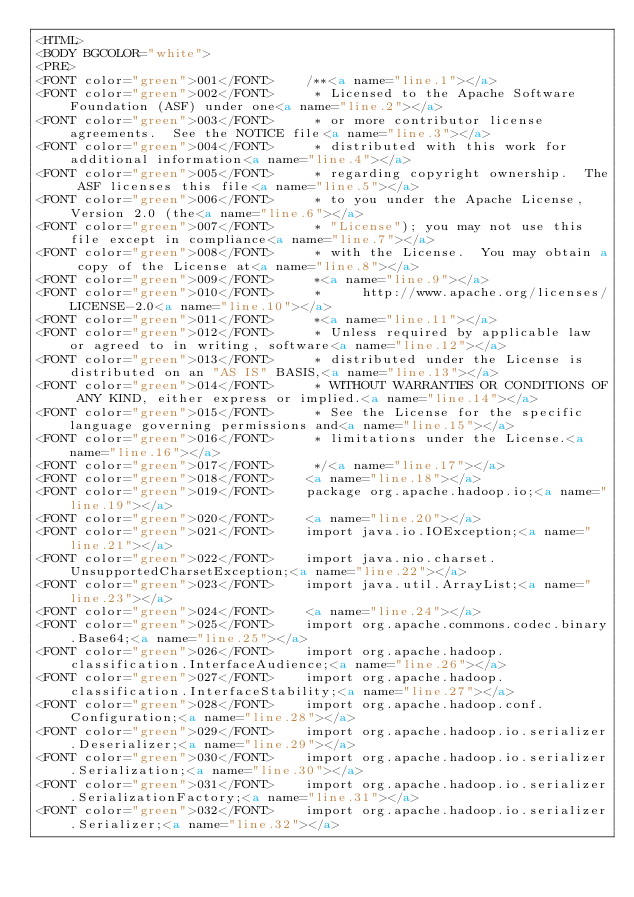<code> <loc_0><loc_0><loc_500><loc_500><_HTML_><HTML>
<BODY BGCOLOR="white">
<PRE>
<FONT color="green">001</FONT>    /**<a name="line.1"></a>
<FONT color="green">002</FONT>     * Licensed to the Apache Software Foundation (ASF) under one<a name="line.2"></a>
<FONT color="green">003</FONT>     * or more contributor license agreements.  See the NOTICE file<a name="line.3"></a>
<FONT color="green">004</FONT>     * distributed with this work for additional information<a name="line.4"></a>
<FONT color="green">005</FONT>     * regarding copyright ownership.  The ASF licenses this file<a name="line.5"></a>
<FONT color="green">006</FONT>     * to you under the Apache License, Version 2.0 (the<a name="line.6"></a>
<FONT color="green">007</FONT>     * "License"); you may not use this file except in compliance<a name="line.7"></a>
<FONT color="green">008</FONT>     * with the License.  You may obtain a copy of the License at<a name="line.8"></a>
<FONT color="green">009</FONT>     *<a name="line.9"></a>
<FONT color="green">010</FONT>     *     http://www.apache.org/licenses/LICENSE-2.0<a name="line.10"></a>
<FONT color="green">011</FONT>     *<a name="line.11"></a>
<FONT color="green">012</FONT>     * Unless required by applicable law or agreed to in writing, software<a name="line.12"></a>
<FONT color="green">013</FONT>     * distributed under the License is distributed on an "AS IS" BASIS,<a name="line.13"></a>
<FONT color="green">014</FONT>     * WITHOUT WARRANTIES OR CONDITIONS OF ANY KIND, either express or implied.<a name="line.14"></a>
<FONT color="green">015</FONT>     * See the License for the specific language governing permissions and<a name="line.15"></a>
<FONT color="green">016</FONT>     * limitations under the License.<a name="line.16"></a>
<FONT color="green">017</FONT>     */<a name="line.17"></a>
<FONT color="green">018</FONT>    <a name="line.18"></a>
<FONT color="green">019</FONT>    package org.apache.hadoop.io;<a name="line.19"></a>
<FONT color="green">020</FONT>    <a name="line.20"></a>
<FONT color="green">021</FONT>    import java.io.IOException;<a name="line.21"></a>
<FONT color="green">022</FONT>    import java.nio.charset.UnsupportedCharsetException;<a name="line.22"></a>
<FONT color="green">023</FONT>    import java.util.ArrayList;<a name="line.23"></a>
<FONT color="green">024</FONT>    <a name="line.24"></a>
<FONT color="green">025</FONT>    import org.apache.commons.codec.binary.Base64;<a name="line.25"></a>
<FONT color="green">026</FONT>    import org.apache.hadoop.classification.InterfaceAudience;<a name="line.26"></a>
<FONT color="green">027</FONT>    import org.apache.hadoop.classification.InterfaceStability;<a name="line.27"></a>
<FONT color="green">028</FONT>    import org.apache.hadoop.conf.Configuration;<a name="line.28"></a>
<FONT color="green">029</FONT>    import org.apache.hadoop.io.serializer.Deserializer;<a name="line.29"></a>
<FONT color="green">030</FONT>    import org.apache.hadoop.io.serializer.Serialization;<a name="line.30"></a>
<FONT color="green">031</FONT>    import org.apache.hadoop.io.serializer.SerializationFactory;<a name="line.31"></a>
<FONT color="green">032</FONT>    import org.apache.hadoop.io.serializer.Serializer;<a name="line.32"></a></code> 